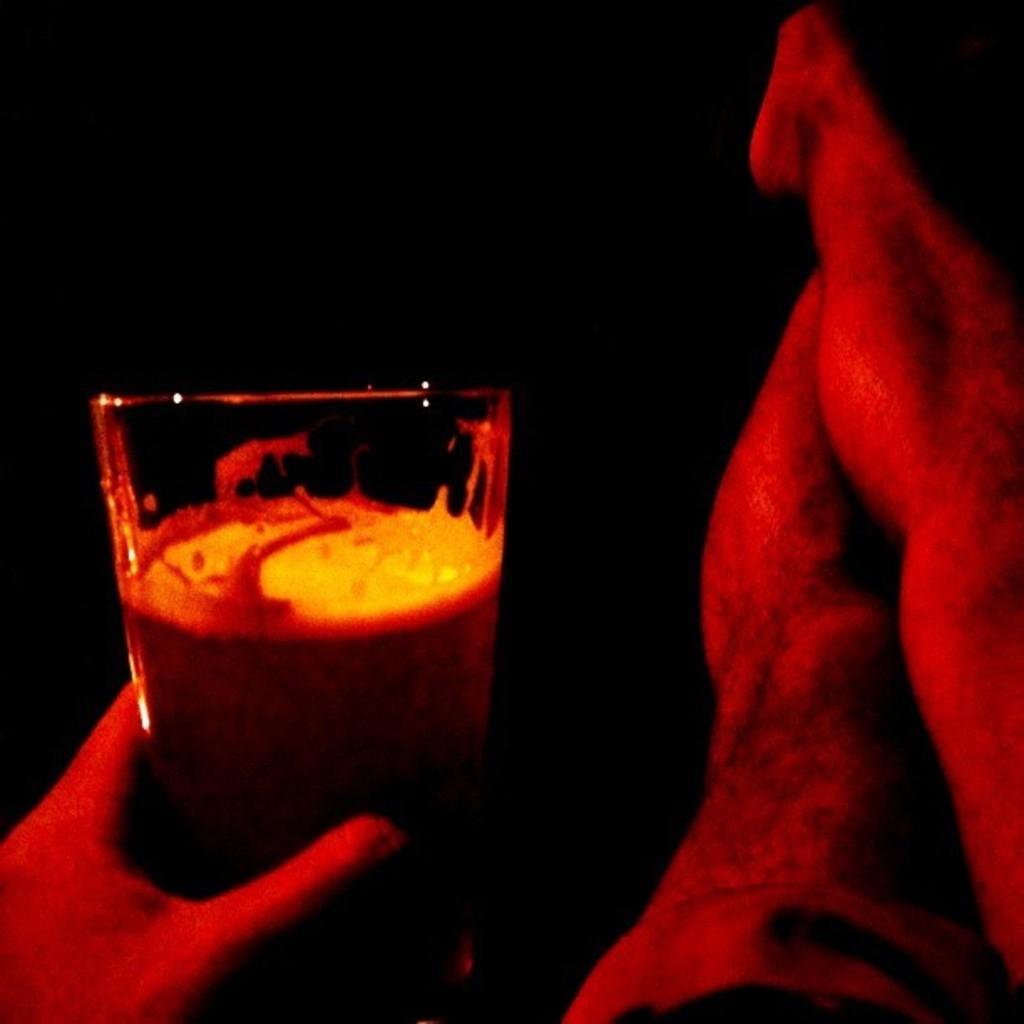In one or two sentences, can you explain what this image depicts? In the foreground of this image, on the right, there are legs of a person and on the left, there is a hand holding a glass. 